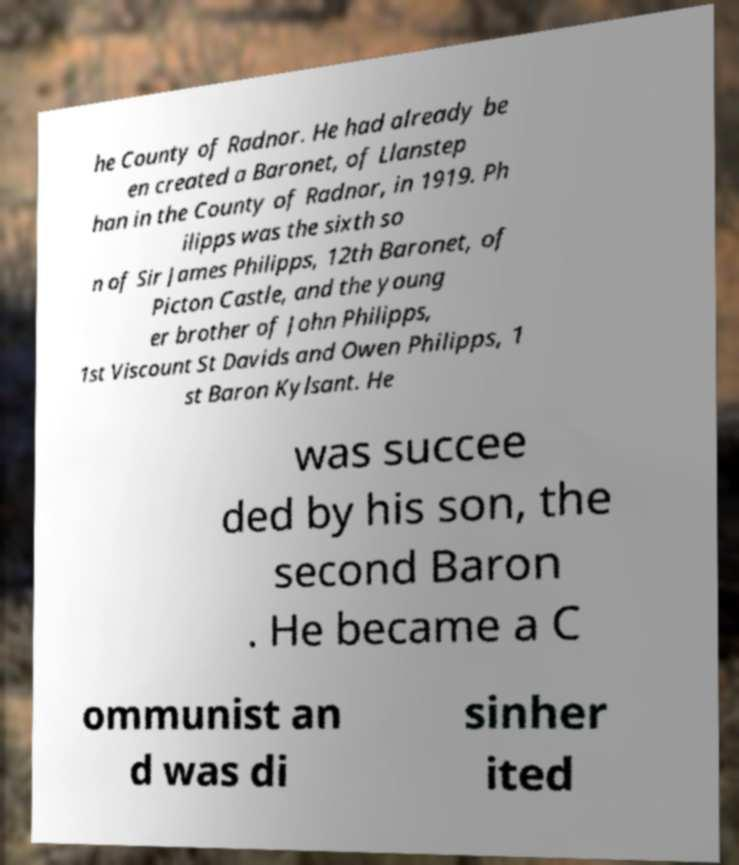For documentation purposes, I need the text within this image transcribed. Could you provide that? he County of Radnor. He had already be en created a Baronet, of Llanstep han in the County of Radnor, in 1919. Ph ilipps was the sixth so n of Sir James Philipps, 12th Baronet, of Picton Castle, and the young er brother of John Philipps, 1st Viscount St Davids and Owen Philipps, 1 st Baron Kylsant. He was succee ded by his son, the second Baron . He became a C ommunist an d was di sinher ited 